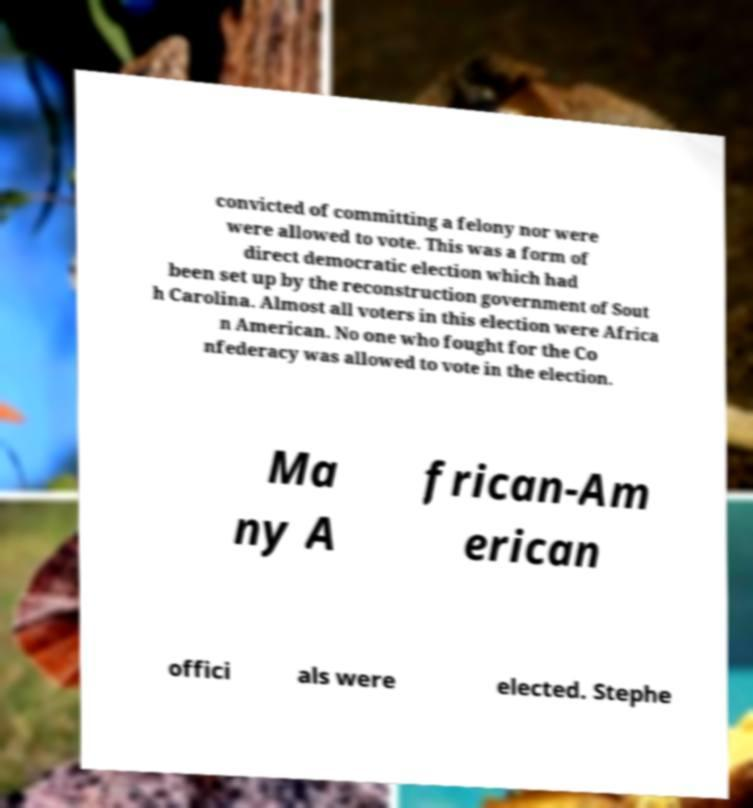Could you extract and type out the text from this image? convicted of committing a felony nor were were allowed to vote. This was a form of direct democratic election which had been set up by the reconstruction government of Sout h Carolina. Almost all voters in this election were Africa n American. No one who fought for the Co nfederacy was allowed to vote in the election. Ma ny A frican-Am erican offici als were elected. Stephe 